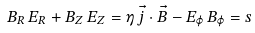Convert formula to latex. <formula><loc_0><loc_0><loc_500><loc_500>B _ { R } \, E _ { R } + B _ { Z } \, E _ { Z } = \eta \, \vec { j } \cdot \vec { B } - E _ { \varphi } \, B _ { \varphi } = s</formula> 